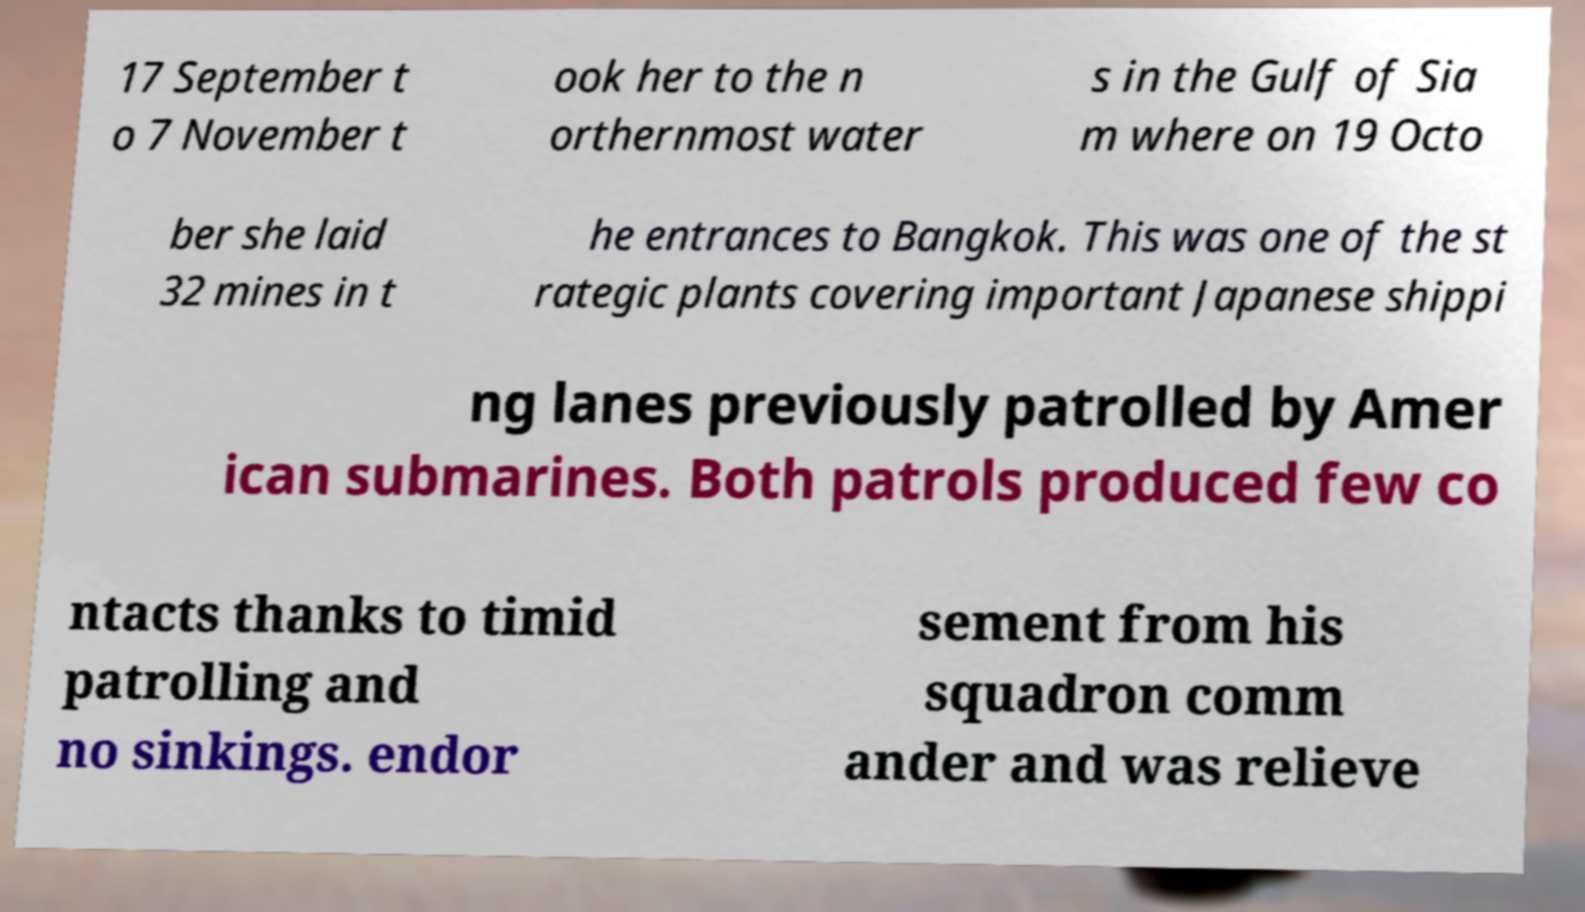I need the written content from this picture converted into text. Can you do that? 17 September t o 7 November t ook her to the n orthernmost water s in the Gulf of Sia m where on 19 Octo ber she laid 32 mines in t he entrances to Bangkok. This was one of the st rategic plants covering important Japanese shippi ng lanes previously patrolled by Amer ican submarines. Both patrols produced few co ntacts thanks to timid patrolling and no sinkings. endor sement from his squadron comm ander and was relieve 